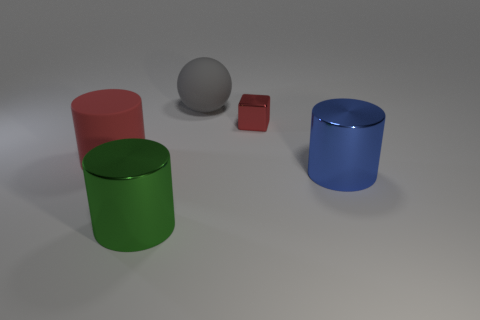There is a blue metal cylinder; is it the same size as the matte object behind the red metallic object? Based on the image, the blue metal cylinder and the matte object, which appears to be a gray sphere behind the small red cube, are not the same size. The sphere is slightly larger in diameter compared to the blue cylinder's height and width. 